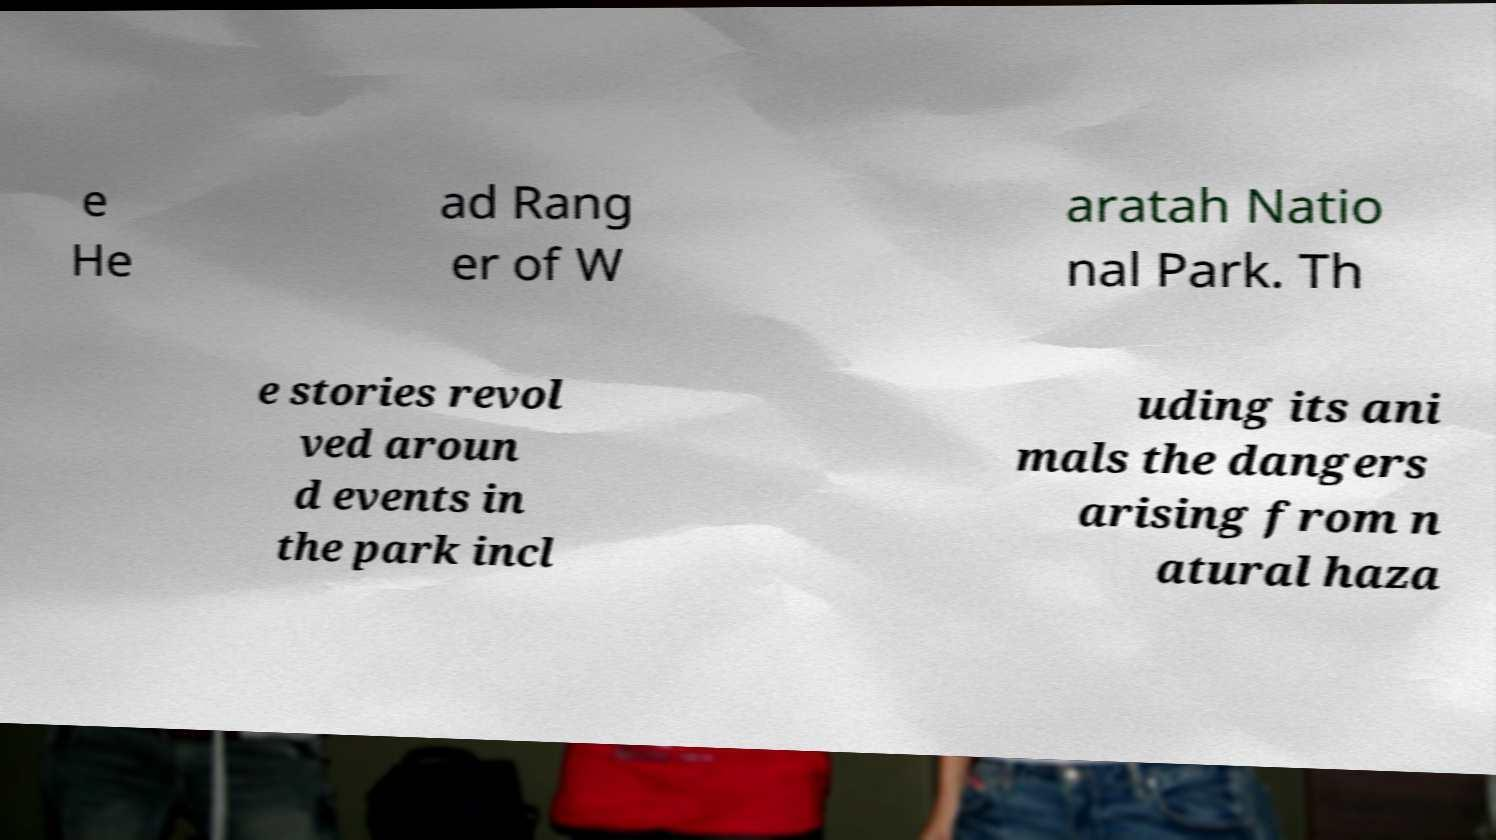Can you accurately transcribe the text from the provided image for me? e He ad Rang er of W aratah Natio nal Park. Th e stories revol ved aroun d events in the park incl uding its ani mals the dangers arising from n atural haza 